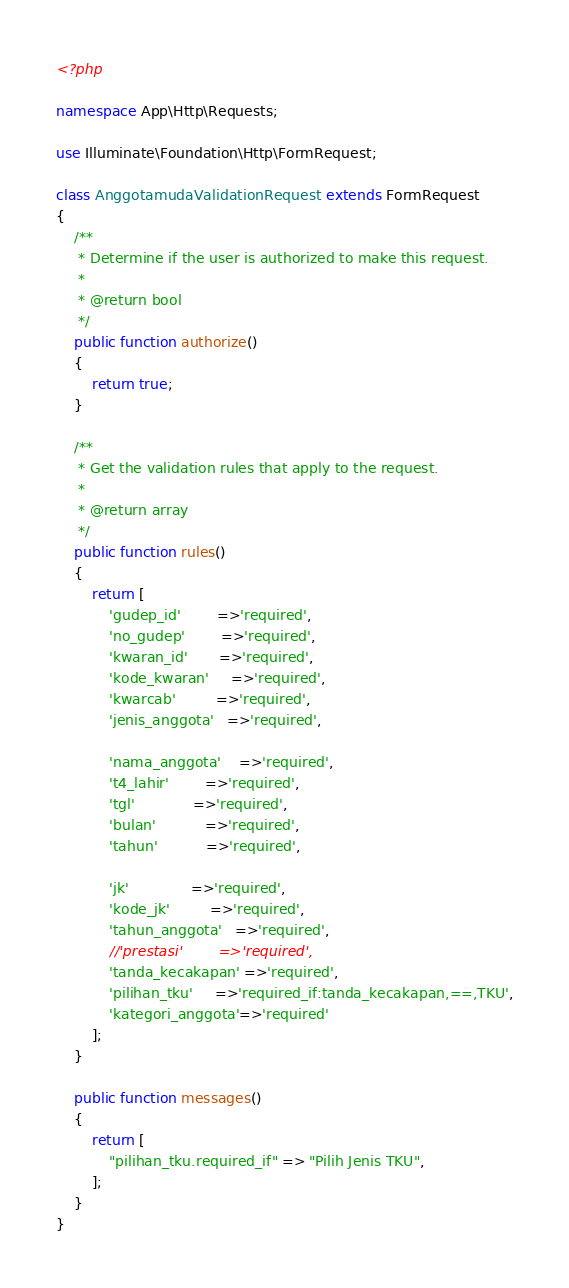<code> <loc_0><loc_0><loc_500><loc_500><_PHP_><?php

namespace App\Http\Requests;

use Illuminate\Foundation\Http\FormRequest;

class AnggotamudaValidationRequest extends FormRequest
{
    /**
     * Determine if the user is authorized to make this request.
     *
     * @return bool
     */
    public function authorize()
    {
        return true;
    }

    /**
     * Get the validation rules that apply to the request.
     *
     * @return array
     */
    public function rules()
    {
        return [
            'gudep_id'        =>'required',
            'no_gudep'        =>'required',
            'kwaran_id'       =>'required',
            'kode_kwaran'     =>'required',
            'kwarcab'         =>'required',
            'jenis_anggota'   =>'required',

            'nama_anggota'    =>'required',
            't4_lahir'        =>'required',
            'tgl'             =>'required', 
            'bulan'           =>'required', 
            'tahun'           =>'required', 

            'jk'              =>'required',
            'kode_jk'         =>'required',
            'tahun_anggota'   =>'required',
            //'prestasi'        =>'required',
            'tanda_kecakapan' =>'required',
            'pilihan_tku'     =>'required_if:tanda_kecakapan,==,TKU',
            'kategori_anggota'=>'required'
        ];
    }

    public function messages()
    {
        return [
            "pilihan_tku.required_if" => "Pilih Jenis TKU",
        ];
    }
}
</code> 